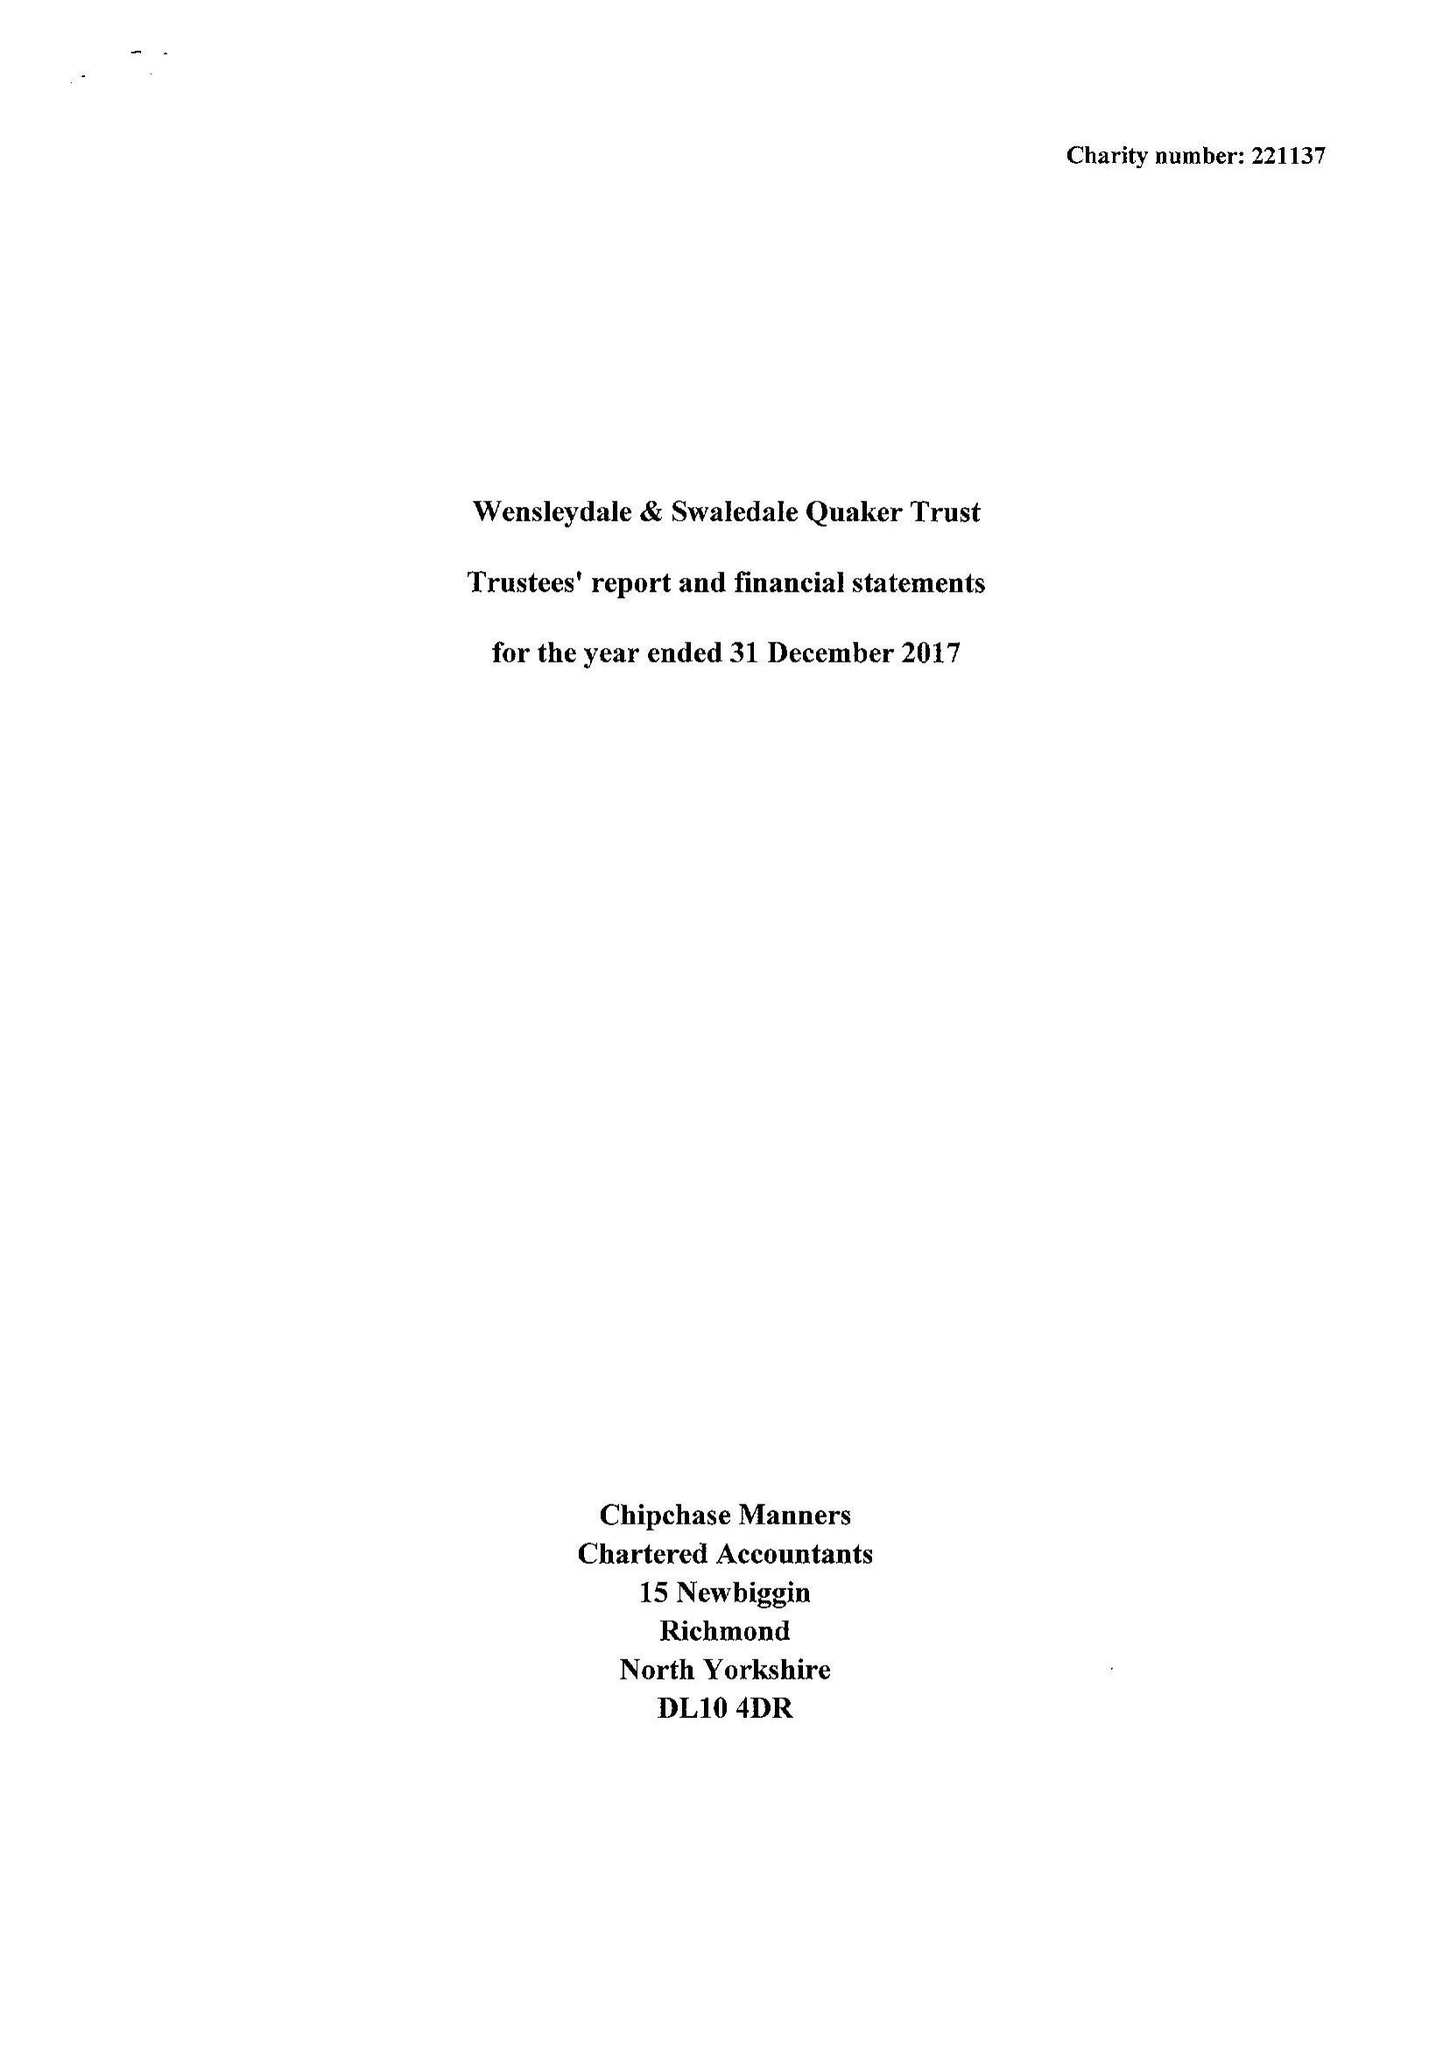What is the value for the income_annually_in_british_pounds?
Answer the question using a single word or phrase. 55532.00 